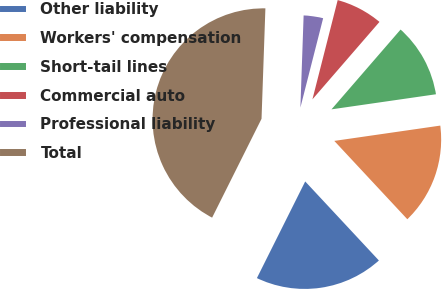Convert chart. <chart><loc_0><loc_0><loc_500><loc_500><pie_chart><fcel>Other liability<fcel>Workers' compensation<fcel>Short-tail lines<fcel>Commercial auto<fcel>Professional liability<fcel>Total<nl><fcel>19.32%<fcel>15.34%<fcel>11.36%<fcel>7.39%<fcel>3.41%<fcel>43.18%<nl></chart> 